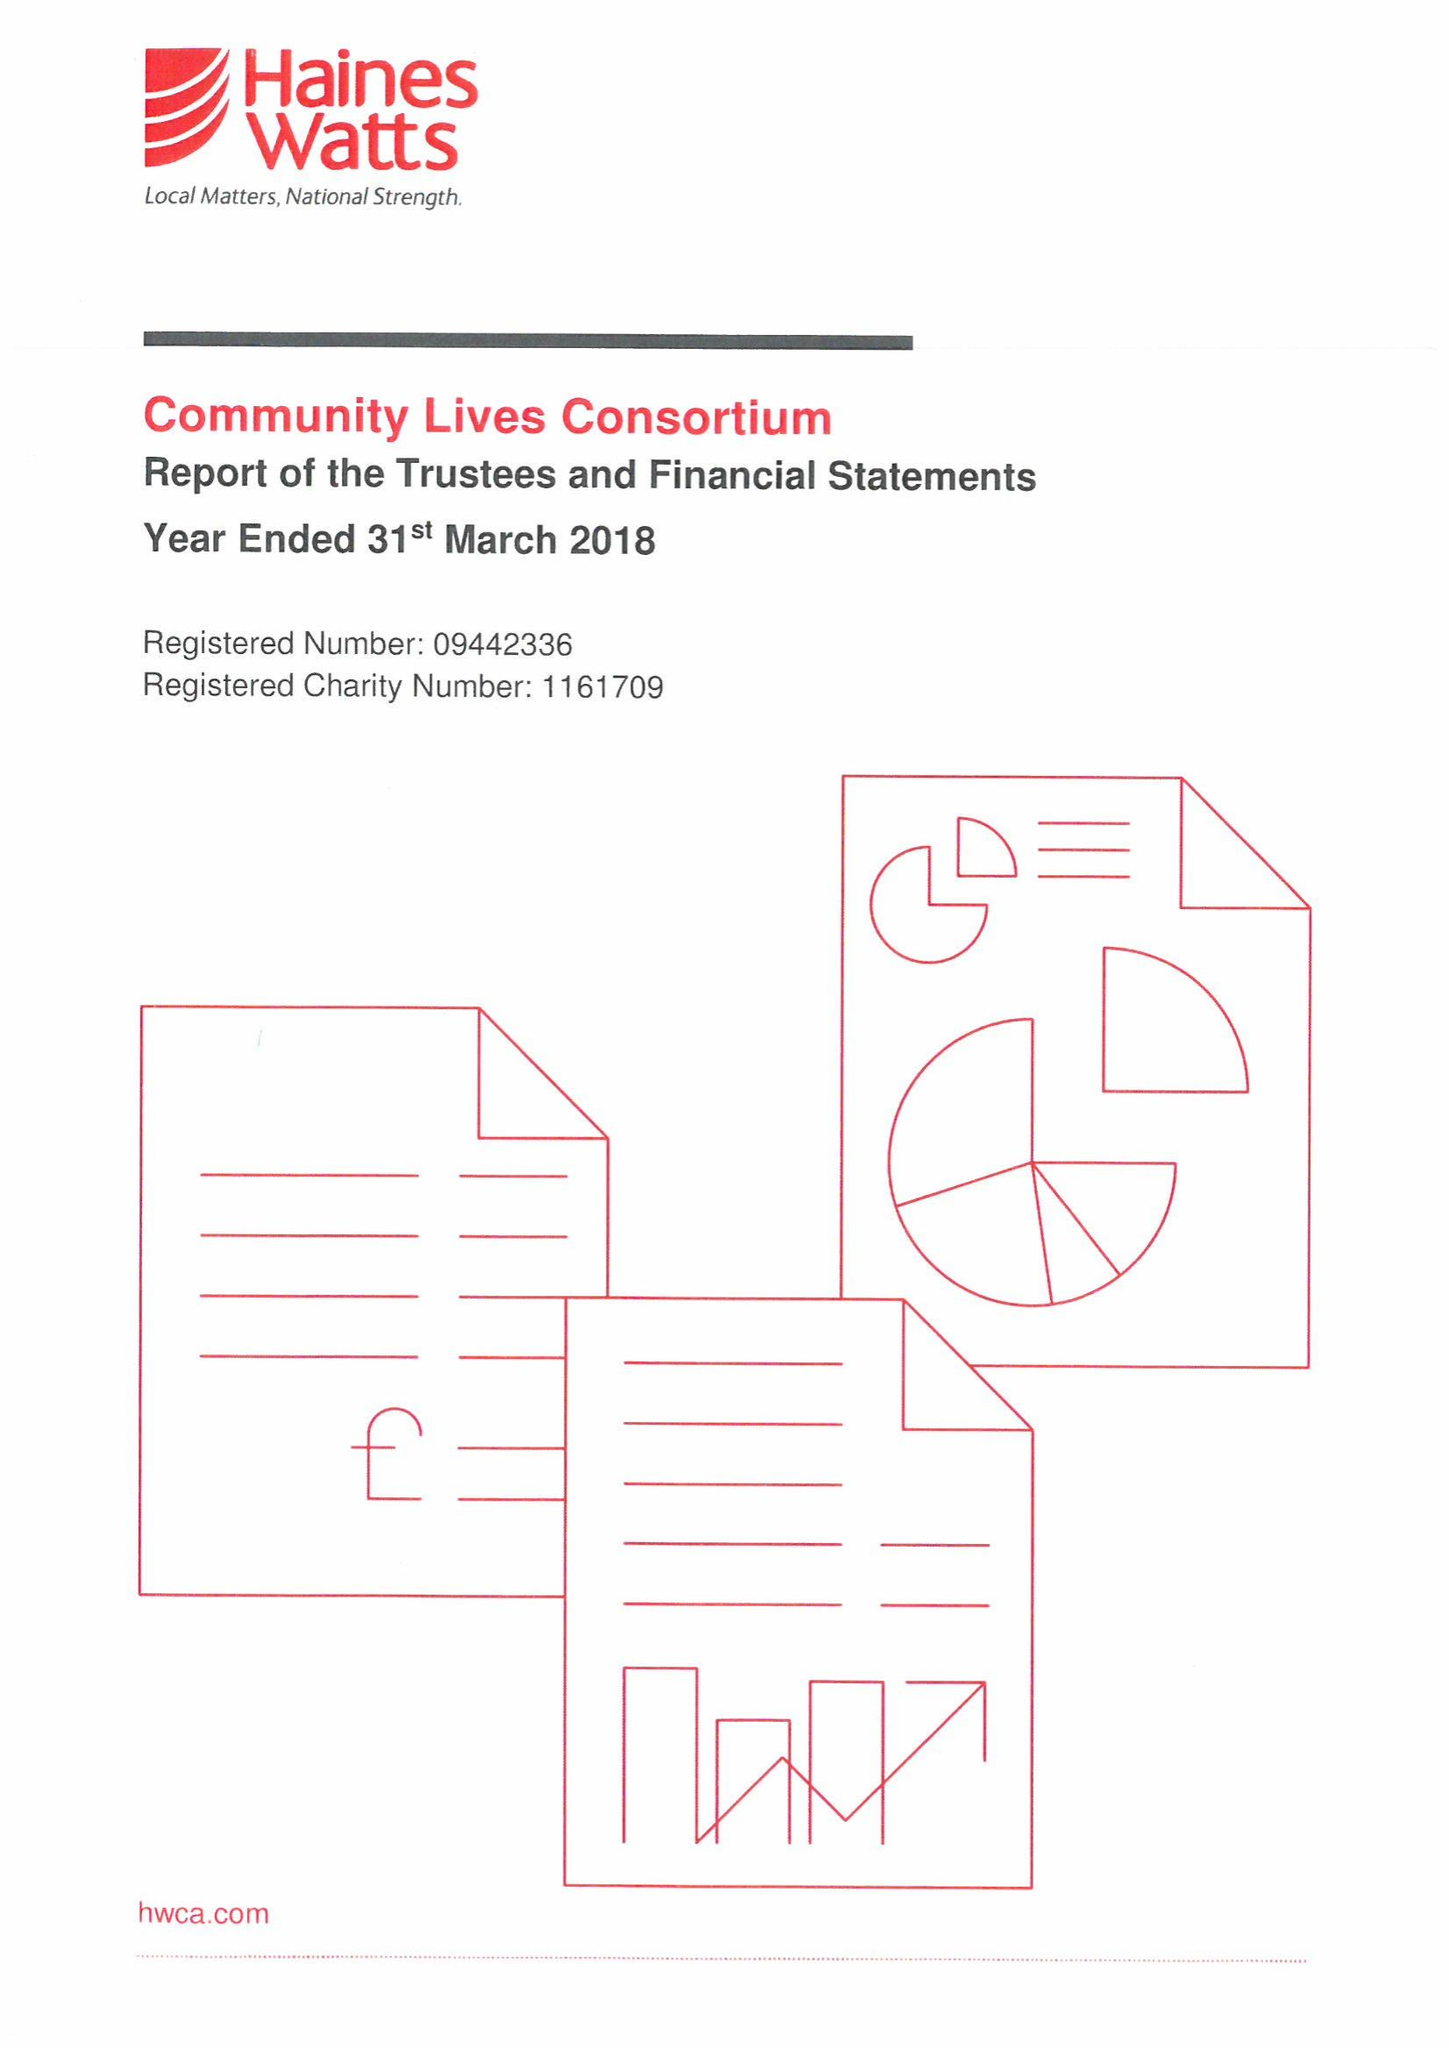What is the value for the address__postcode?
Answer the question using a single word or phrase. SA1 5NN 